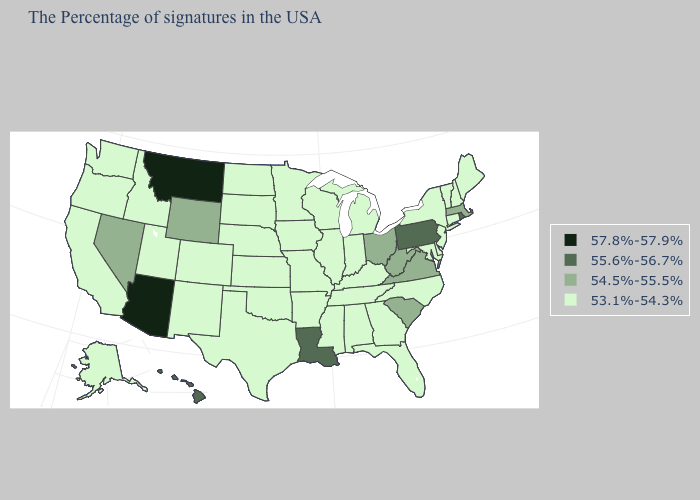Which states have the highest value in the USA?
Answer briefly. Montana, Arizona. What is the lowest value in the USA?
Keep it brief. 53.1%-54.3%. What is the value of Illinois?
Keep it brief. 53.1%-54.3%. Which states have the lowest value in the USA?
Quick response, please. Maine, New Hampshire, Vermont, Connecticut, New York, New Jersey, Delaware, Maryland, North Carolina, Florida, Georgia, Michigan, Kentucky, Indiana, Alabama, Tennessee, Wisconsin, Illinois, Mississippi, Missouri, Arkansas, Minnesota, Iowa, Kansas, Nebraska, Oklahoma, Texas, South Dakota, North Dakota, Colorado, New Mexico, Utah, Idaho, California, Washington, Oregon, Alaska. Which states hav the highest value in the West?
Keep it brief. Montana, Arizona. Does the first symbol in the legend represent the smallest category?
Quick response, please. No. What is the value of Illinois?
Write a very short answer. 53.1%-54.3%. What is the value of Iowa?
Give a very brief answer. 53.1%-54.3%. Does the first symbol in the legend represent the smallest category?
Give a very brief answer. No. What is the lowest value in the USA?
Be succinct. 53.1%-54.3%. What is the value of Iowa?
Quick response, please. 53.1%-54.3%. Name the states that have a value in the range 53.1%-54.3%?
Give a very brief answer. Maine, New Hampshire, Vermont, Connecticut, New York, New Jersey, Delaware, Maryland, North Carolina, Florida, Georgia, Michigan, Kentucky, Indiana, Alabama, Tennessee, Wisconsin, Illinois, Mississippi, Missouri, Arkansas, Minnesota, Iowa, Kansas, Nebraska, Oklahoma, Texas, South Dakota, North Dakota, Colorado, New Mexico, Utah, Idaho, California, Washington, Oregon, Alaska. Does South Carolina have the same value as Illinois?
Keep it brief. No. 